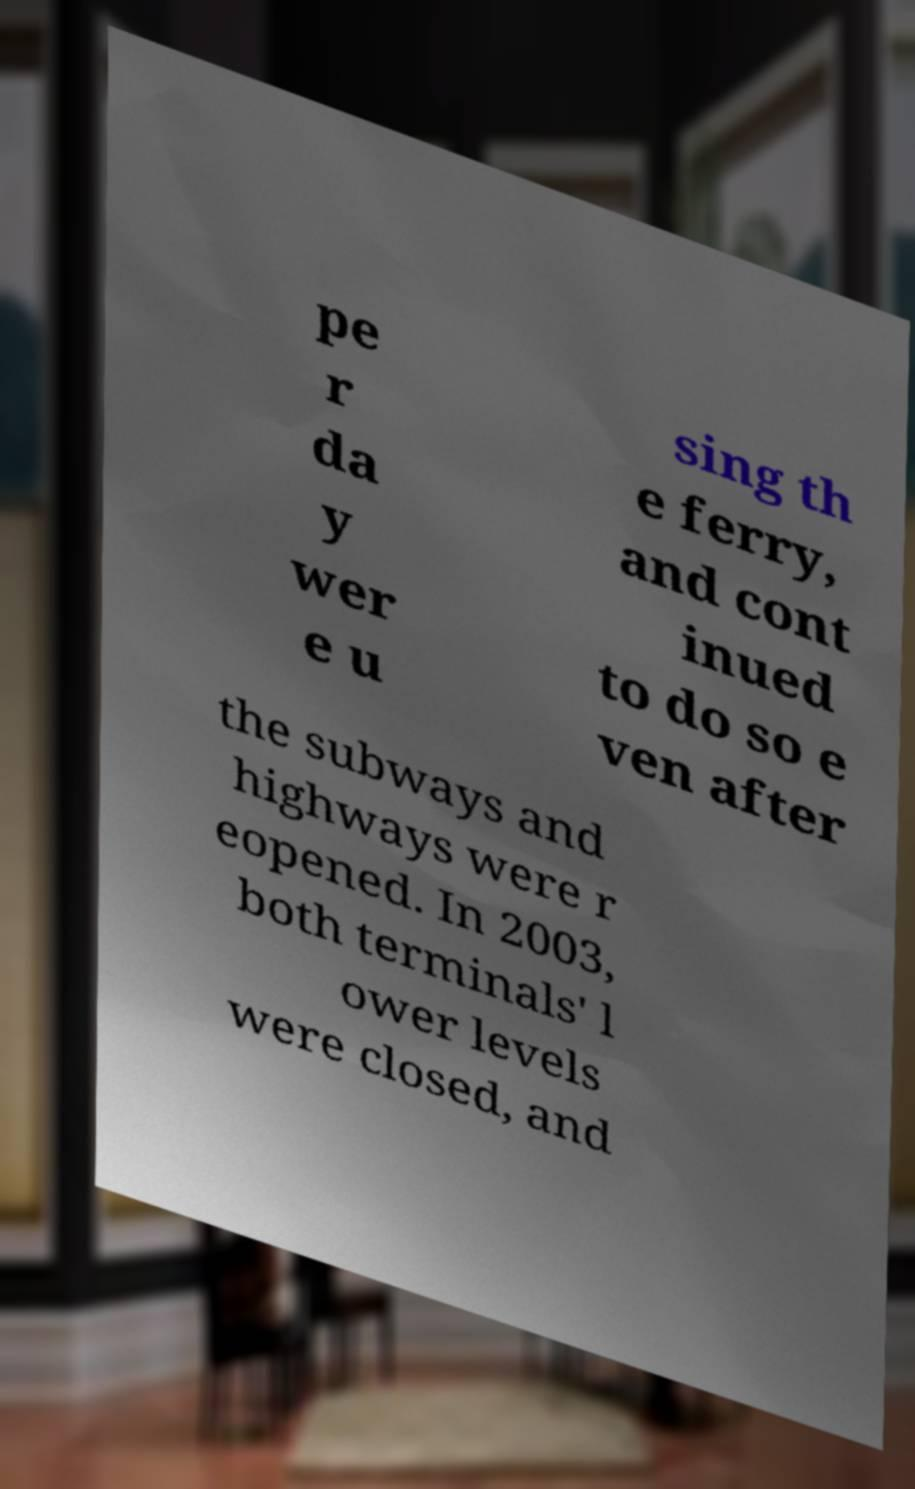I need the written content from this picture converted into text. Can you do that? pe r da y wer e u sing th e ferry, and cont inued to do so e ven after the subways and highways were r eopened. In 2003, both terminals' l ower levels were closed, and 